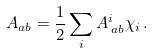<formula> <loc_0><loc_0><loc_500><loc_500>A _ { a b } = \frac { 1 } { 2 } \sum _ { i } A ^ { i } _ { \, a b } \chi _ { i } \, .</formula> 